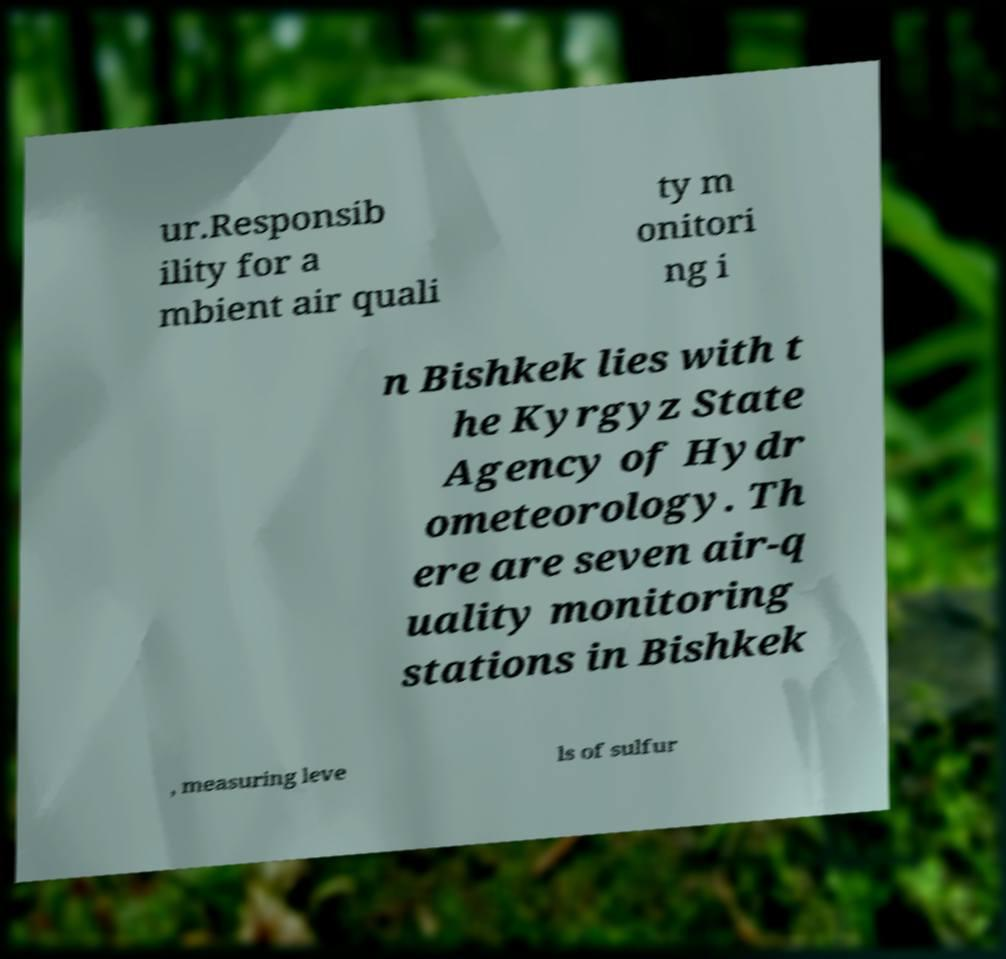There's text embedded in this image that I need extracted. Can you transcribe it verbatim? ur.Responsib ility for a mbient air quali ty m onitori ng i n Bishkek lies with t he Kyrgyz State Agency of Hydr ometeorology. Th ere are seven air-q uality monitoring stations in Bishkek , measuring leve ls of sulfur 